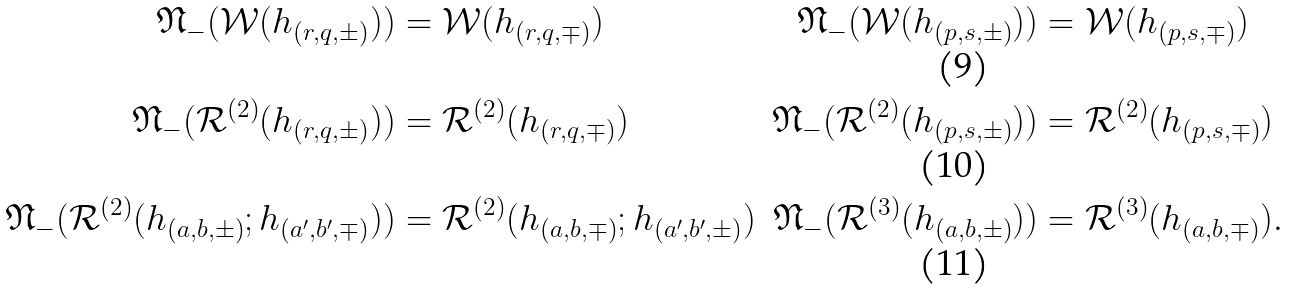Convert formula to latex. <formula><loc_0><loc_0><loc_500><loc_500>\mathfrak { N } _ { - } ( \mathcal { W } ( h _ { ( r , q , \pm ) } ) ) & = \mathcal { W } ( h _ { ( r , q , \mp ) } ) & \mathfrak { N } _ { - } ( \mathcal { W } ( h _ { ( p , s , \pm ) } ) ) & = \mathcal { W } ( h _ { ( p , s , \mp ) } ) \\ \mathfrak { N } _ { - } ( \mathcal { R } ^ { ( 2 ) } ( h _ { ( r , q , \pm ) } ) ) & = \mathcal { R } ^ { ( 2 ) } ( h _ { ( r , q , \mp ) } ) & \mathfrak { N } _ { - } ( \mathcal { R } ^ { ( 2 ) } ( h _ { ( p , s , \pm ) } ) ) & = \mathcal { R } ^ { ( 2 ) } ( h _ { ( p , s , \mp ) } ) \\ \mathfrak { N } _ { - } ( \mathcal { R } ^ { ( 2 ) } ( h _ { ( a , b , \pm ) } ; h _ { ( a ^ { \prime } , b ^ { \prime } , \mp ) } ) ) & = \mathcal { R } ^ { ( 2 ) } ( h _ { ( a , b , \mp ) } ; h _ { ( a ^ { \prime } , b ^ { \prime } , \pm ) } ) & \mathfrak { N } _ { - } ( \mathcal { R } ^ { ( 3 ) } ( h _ { ( a , b , \pm ) } ) ) & = \mathcal { R } ^ { ( 3 ) } ( h _ { ( a , b , \mp ) } ) .</formula> 